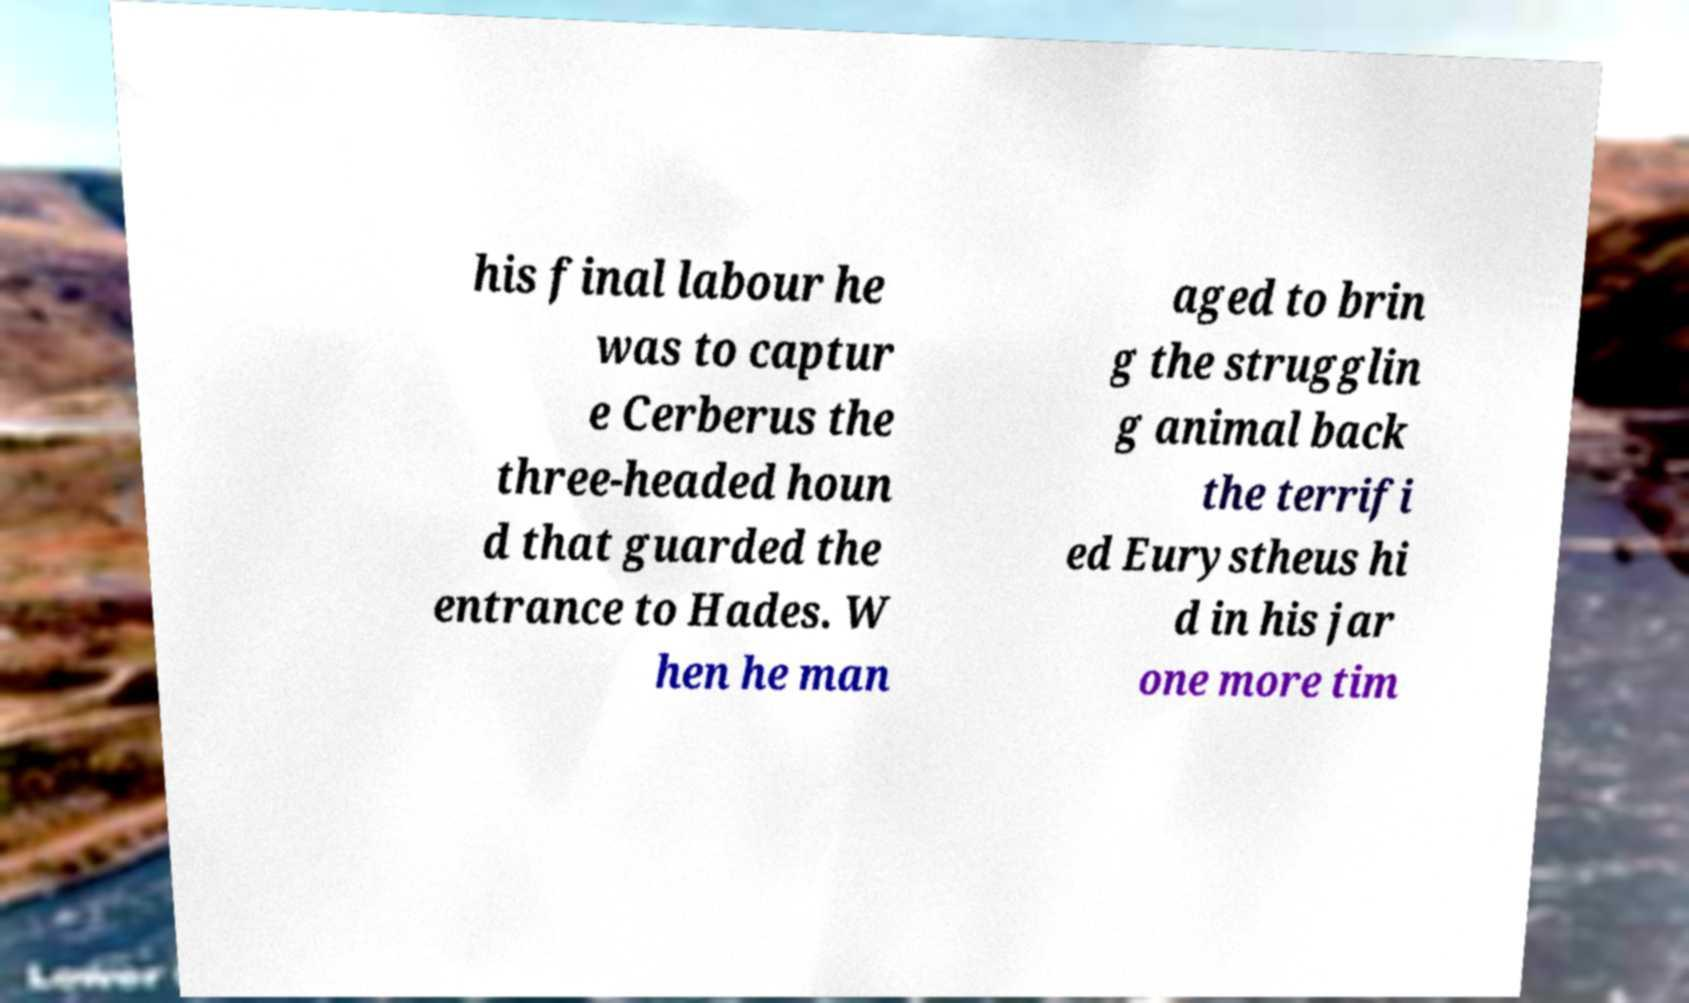Please read and relay the text visible in this image. What does it say? his final labour he was to captur e Cerberus the three-headed houn d that guarded the entrance to Hades. W hen he man aged to brin g the strugglin g animal back the terrifi ed Eurystheus hi d in his jar one more tim 